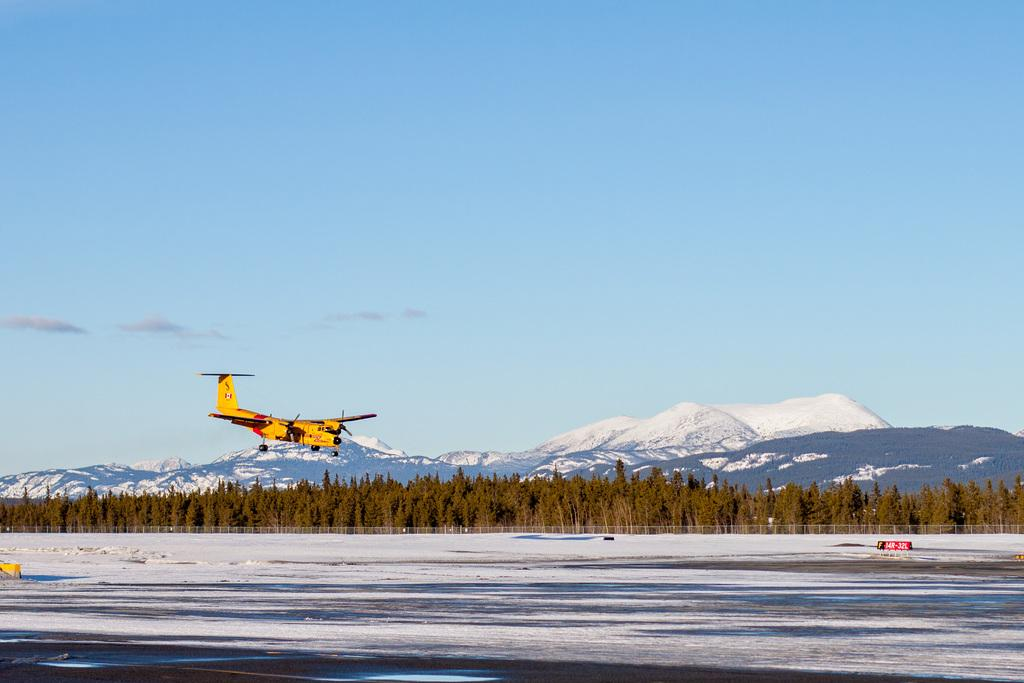What is the main subject of the image? The main subject of the image is an aircraft. Where is the aircraft located in the image? The aircraft is at the bottom of the image. What can be seen on the land in the image? There is snow on the land in the image. What is visible in the background of the image? There are trees, mountains, and the sky visible in the background of the image. What type of music can be heard coming from the stage in the image? There is no stage or music present in the image; it features an aircraft in a snowy landscape with trees, mountains, and the sky in the background. 